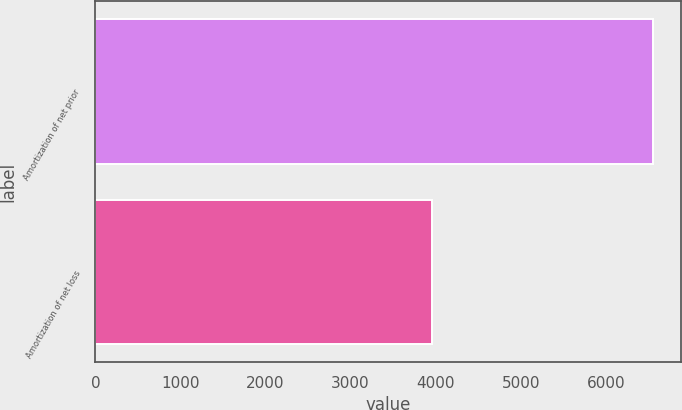Convert chart. <chart><loc_0><loc_0><loc_500><loc_500><bar_chart><fcel>Amortization of net prior<fcel>Amortization of net loss<nl><fcel>6559<fcel>3954<nl></chart> 